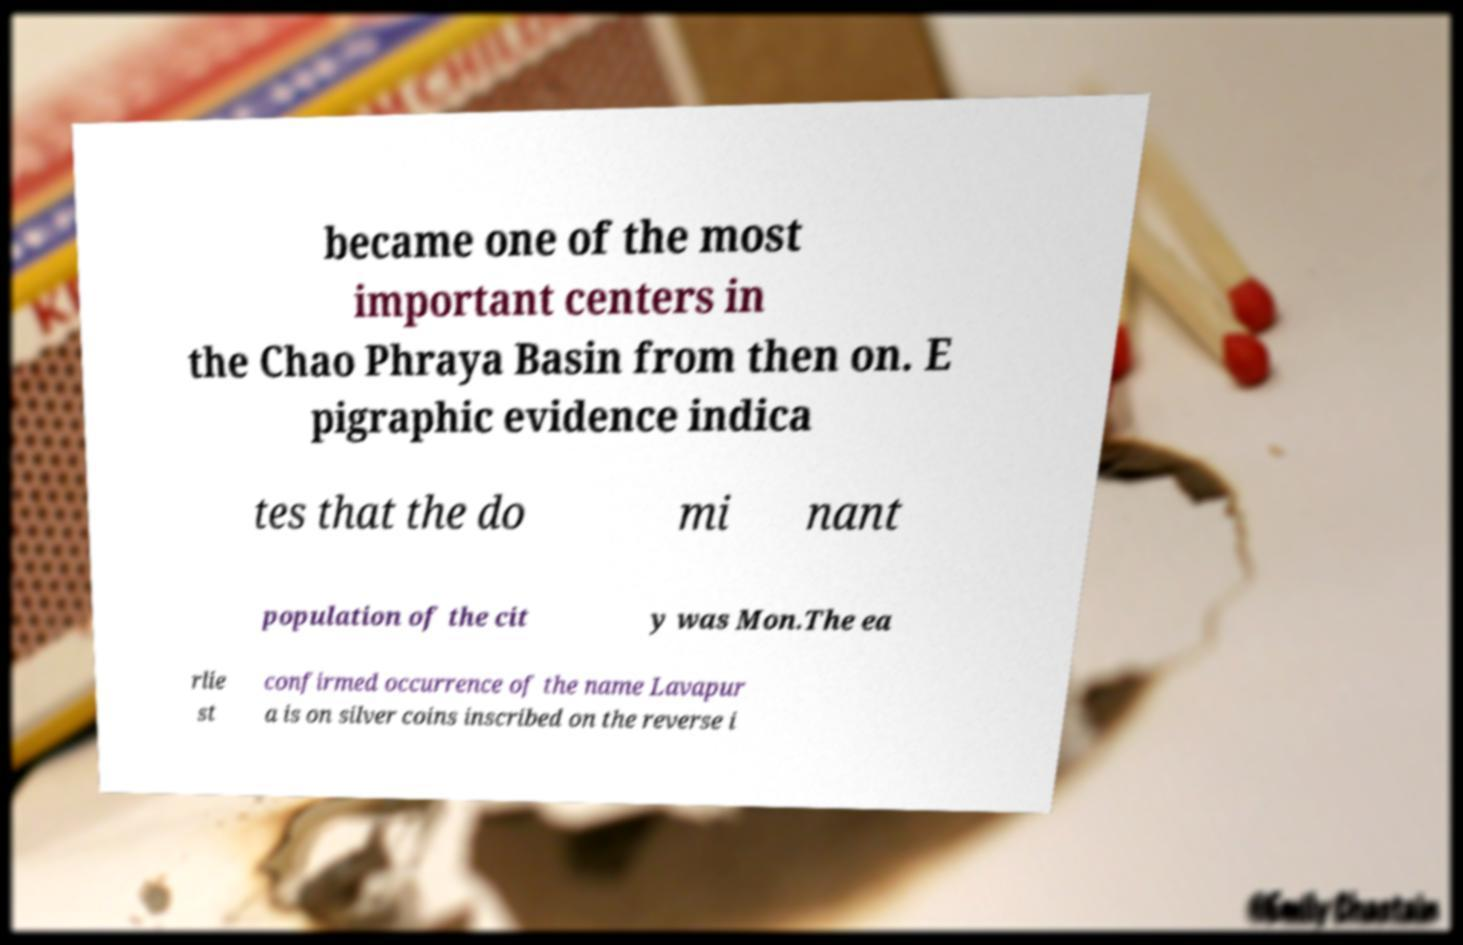I need the written content from this picture converted into text. Can you do that? became one of the most important centers in the Chao Phraya Basin from then on. E pigraphic evidence indica tes that the do mi nant population of the cit y was Mon.The ea rlie st confirmed occurrence of the name Lavapur a is on silver coins inscribed on the reverse i 